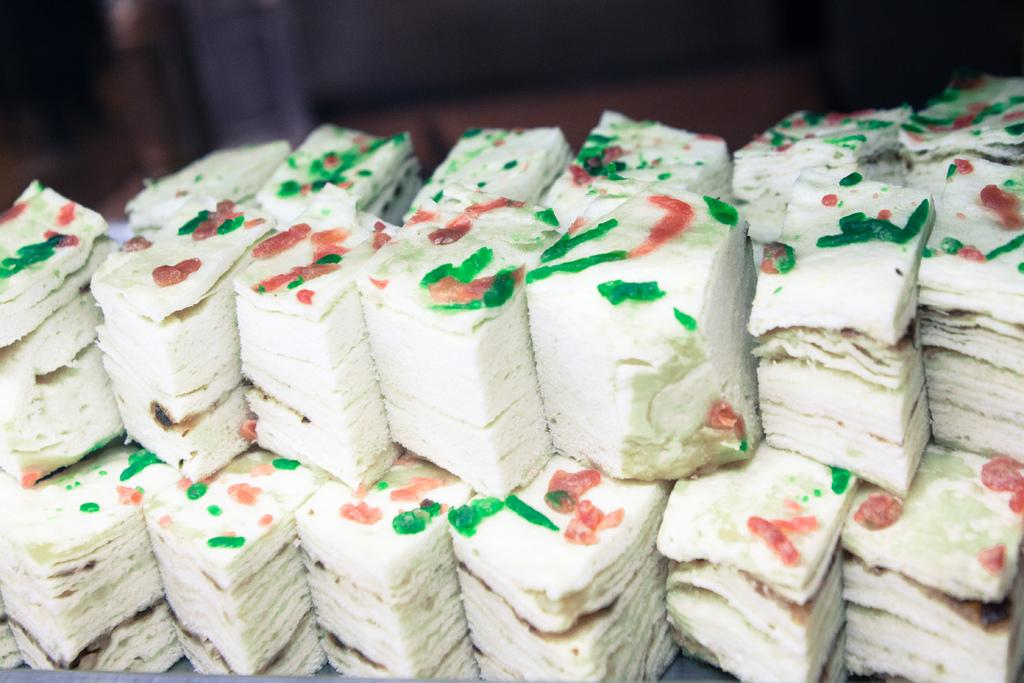What type of food can be seen in the image? There are small cake pieces in the image. What type of zipper can be seen on the skirt in the image? There is no zipper or skirt present in the image; it only features small cake pieces. 